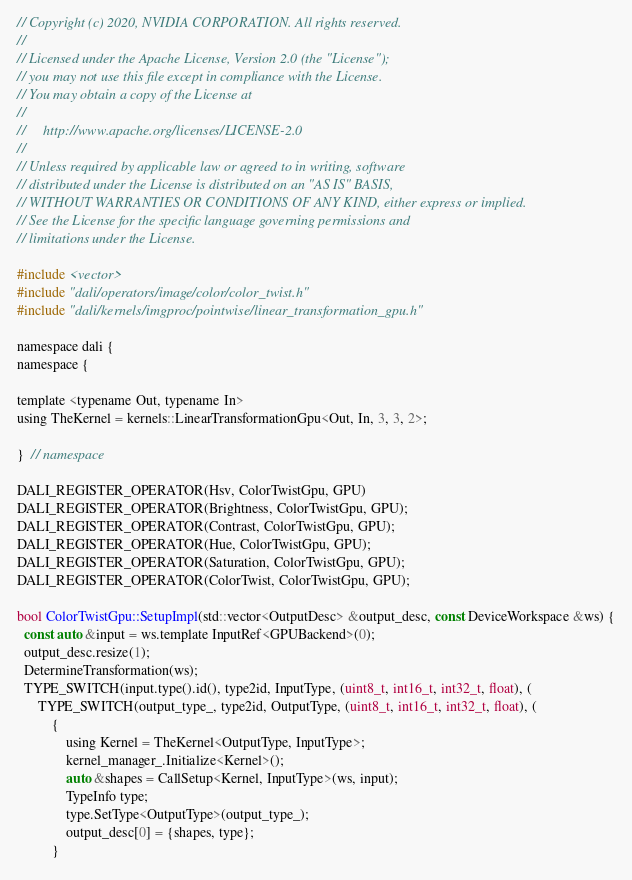<code> <loc_0><loc_0><loc_500><loc_500><_Cuda_>// Copyright (c) 2020, NVIDIA CORPORATION. All rights reserved.
//
// Licensed under the Apache License, Version 2.0 (the "License");
// you may not use this file except in compliance with the License.
// You may obtain a copy of the License at
//
//     http://www.apache.org/licenses/LICENSE-2.0
//
// Unless required by applicable law or agreed to in writing, software
// distributed under the License is distributed on an "AS IS" BASIS,
// WITHOUT WARRANTIES OR CONDITIONS OF ANY KIND, either express or implied.
// See the License for the specific language governing permissions and
// limitations under the License.

#include <vector>
#include "dali/operators/image/color/color_twist.h"
#include "dali/kernels/imgproc/pointwise/linear_transformation_gpu.h"

namespace dali {
namespace {

template <typename Out, typename In>
using TheKernel = kernels::LinearTransformationGpu<Out, In, 3, 3, 2>;

}  // namespace

DALI_REGISTER_OPERATOR(Hsv, ColorTwistGpu, GPU)
DALI_REGISTER_OPERATOR(Brightness, ColorTwistGpu, GPU);
DALI_REGISTER_OPERATOR(Contrast, ColorTwistGpu, GPU);
DALI_REGISTER_OPERATOR(Hue, ColorTwistGpu, GPU);
DALI_REGISTER_OPERATOR(Saturation, ColorTwistGpu, GPU);
DALI_REGISTER_OPERATOR(ColorTwist, ColorTwistGpu, GPU);

bool ColorTwistGpu::SetupImpl(std::vector<OutputDesc> &output_desc, const DeviceWorkspace &ws) {
  const auto &input = ws.template InputRef<GPUBackend>(0);
  output_desc.resize(1);
  DetermineTransformation(ws);
  TYPE_SWITCH(input.type().id(), type2id, InputType, (uint8_t, int16_t, int32_t, float), (
      TYPE_SWITCH(output_type_, type2id, OutputType, (uint8_t, int16_t, int32_t, float), (
          {
              using Kernel = TheKernel<OutputType, InputType>;
              kernel_manager_.Initialize<Kernel>();
              auto &shapes = CallSetup<Kernel, InputType>(ws, input);
              TypeInfo type;
              type.SetType<OutputType>(output_type_);
              output_desc[0] = {shapes, type};
          }</code> 